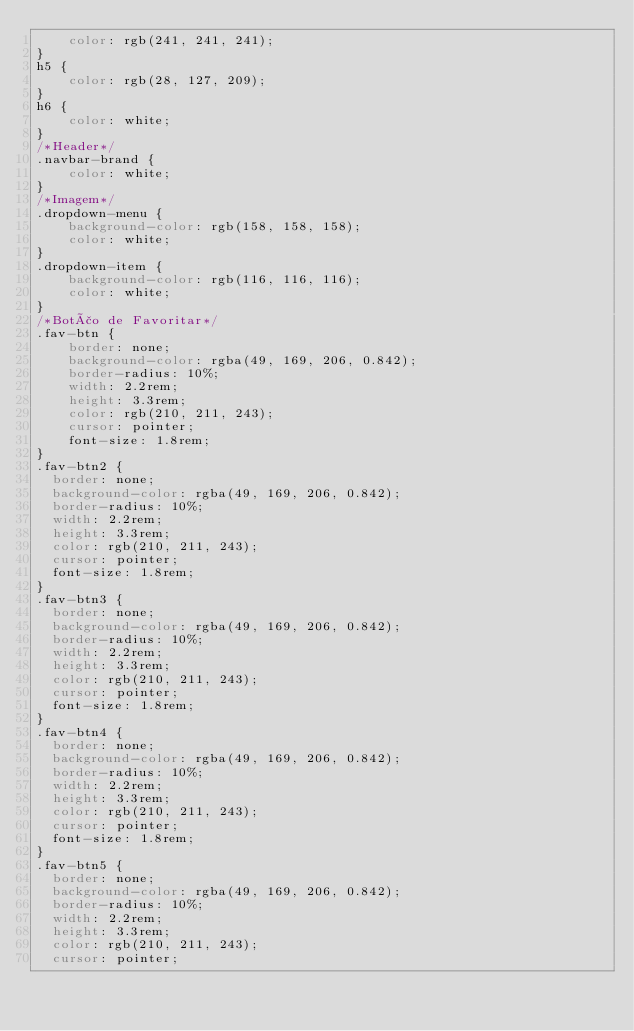<code> <loc_0><loc_0><loc_500><loc_500><_CSS_>    color: rgb(241, 241, 241);
}
h5 {
    color: rgb(28, 127, 209);
}
h6 {
    color: white;
}
/*Header*/
.navbar-brand {
    color: white;
}
/*Imagem*/
.dropdown-menu {
    background-color: rgb(158, 158, 158);
    color: white;
}
.dropdown-item {
    background-color: rgb(116, 116, 116);
    color: white;
}
/*Botão de Favoritar*/
.fav-btn {
    border: none;
    background-color: rgba(49, 169, 206, 0.842);
    border-radius: 10%;
    width: 2.2rem;
    height: 3.3rem;
    color: rgb(210, 211, 243);
    cursor: pointer;
    font-size: 1.8rem;
}
.fav-btn2 {
  border: none;
  background-color: rgba(49, 169, 206, 0.842);
  border-radius: 10%;
  width: 2.2rem;
  height: 3.3rem;
  color: rgb(210, 211, 243);
  cursor: pointer;
  font-size: 1.8rem;
}
.fav-btn3 {
  border: none;
  background-color: rgba(49, 169, 206, 0.842);
  border-radius: 10%;
  width: 2.2rem;
  height: 3.3rem;
  color: rgb(210, 211, 243);
  cursor: pointer;
  font-size: 1.8rem;
}
.fav-btn4 {
  border: none;
  background-color: rgba(49, 169, 206, 0.842);
  border-radius: 10%;
  width: 2.2rem;
  height: 3.3rem;
  color: rgb(210, 211, 243);
  cursor: pointer;
  font-size: 1.8rem;
}
.fav-btn5 {
  border: none;
  background-color: rgba(49, 169, 206, 0.842);
  border-radius: 10%;
  width: 2.2rem;
  height: 3.3rem;
  color: rgb(210, 211, 243);
  cursor: pointer;</code> 